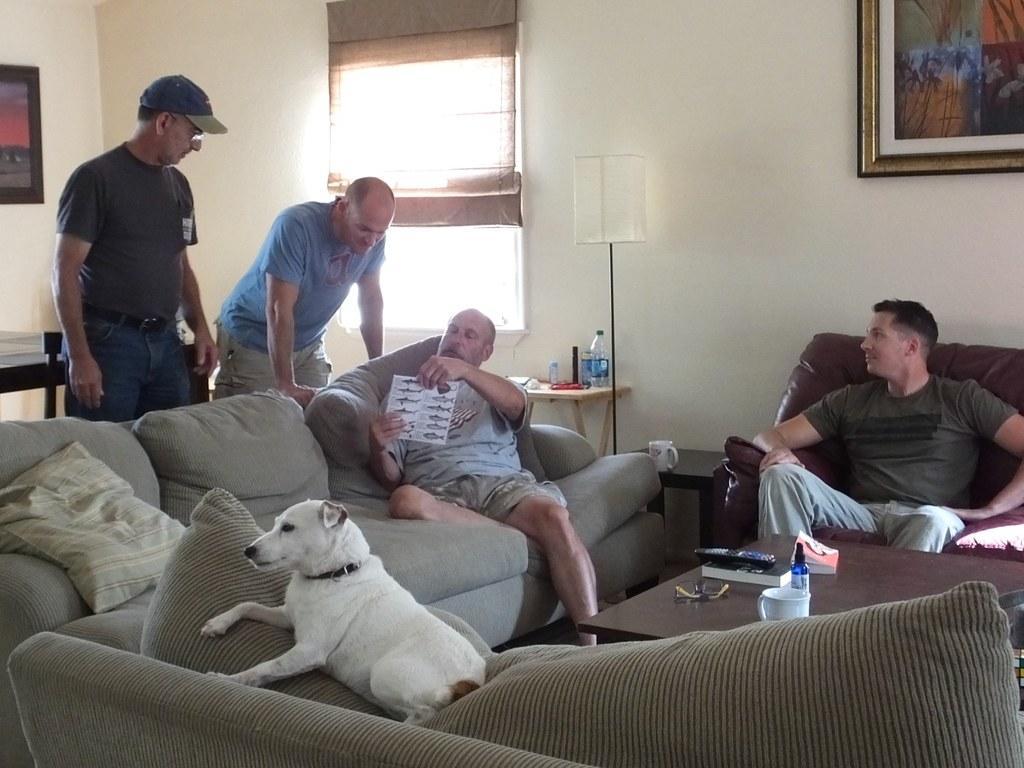In one or two sentences, can you explain what this image depicts? In this picture we can see two men sitting on sofa and holding paper in his hand and other two men are standing and looking at him and we have dog on sofa and pillow and in background we can see wall, frames, window, bottle, some items on table, lamp. 